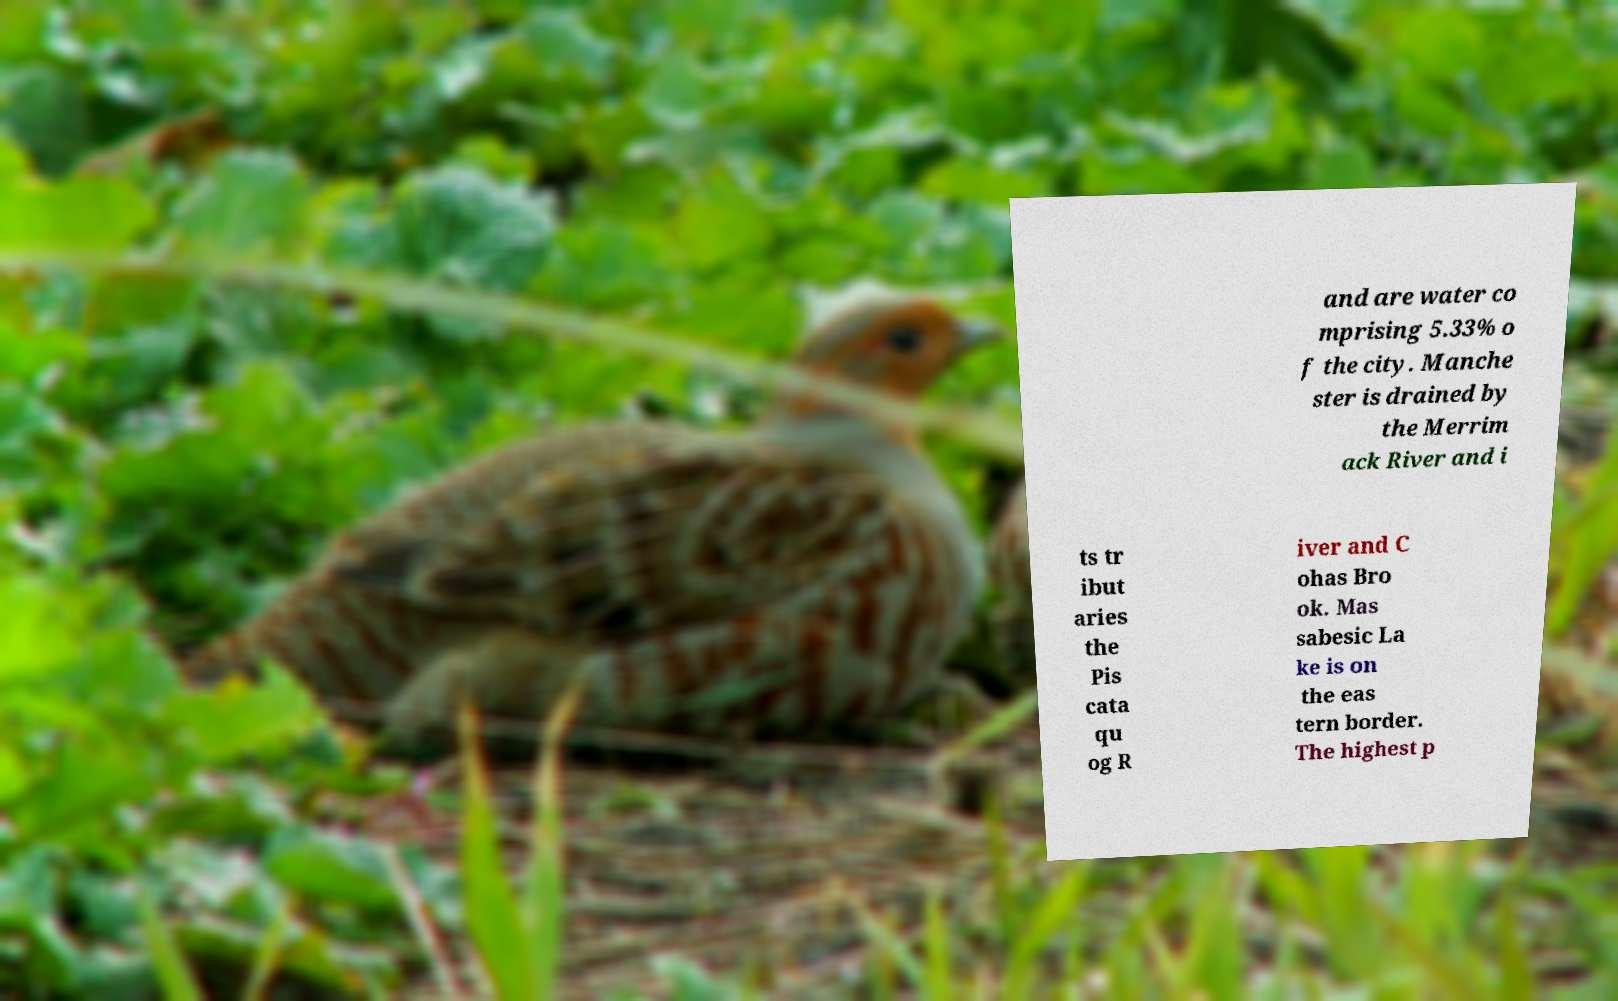I need the written content from this picture converted into text. Can you do that? and are water co mprising 5.33% o f the city. Manche ster is drained by the Merrim ack River and i ts tr ibut aries the Pis cata qu og R iver and C ohas Bro ok. Mas sabesic La ke is on the eas tern border. The highest p 